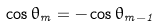Convert formula to latex. <formula><loc_0><loc_0><loc_500><loc_500>\cos \theta _ { m } = - \cos \theta _ { m - 1 }</formula> 